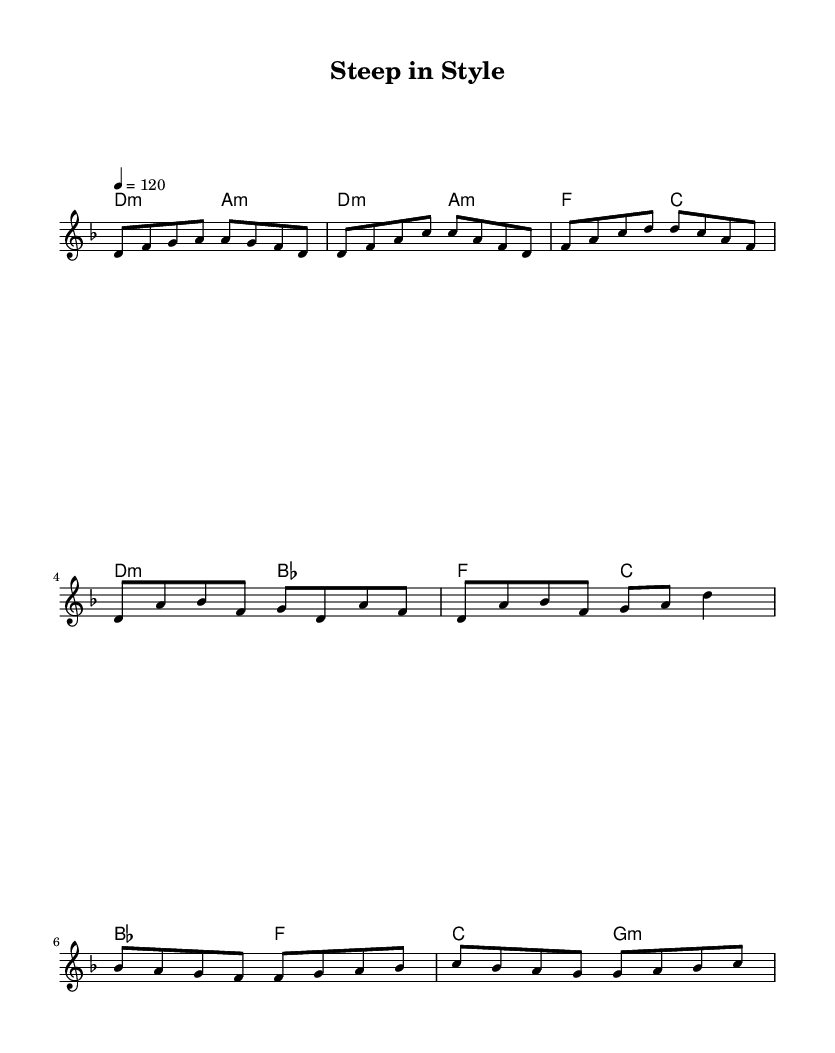What is the key signature of this music? The key signature is indicated on the staff at the beginning of the piece. Here, it shows one flat, which corresponds to D minor.
Answer: D minor What is the time signature of this music? The time signature is found at the beginning of the score and is indicated by the "4/4" notation. This means there are four beats in each measure, with a quarter note receiving one beat.
Answer: 4/4 What is the tempo marking for this piece? The tempo is indicated above the staff by the text "4 = 120", which specifies the beats per minute that the music should be played.
Answer: 120 How many measures are present in the verse section? The verse section can be identified from the structure provided in the melody part. It consists of two groups of four beats, which results in 8 measure counts.
Answer: 8 What kind of chords are used in the intro? By looking at the harmonies presented at the beginning of the score, the chords listed are both D minor and A minor, as indicated under the bullet points for the intro.
Answer: D minor, A minor How does the chorus differ harmonically from the verse? The chorus section switches from the D minor and A minor combination to D minor and B flat major, indicating a harmonic variation from what is presented in the verse, which retains D minor and A minor.
Answer: D minor, B flat major What is the primary thematic focus of the song as indicated by the title? The title "Steep in Style" suggests that the theme revolves around tea culture and its artistic representation, aligning with the fashion elements reflected in the music structure.
Answer: Tea culture and fashion 